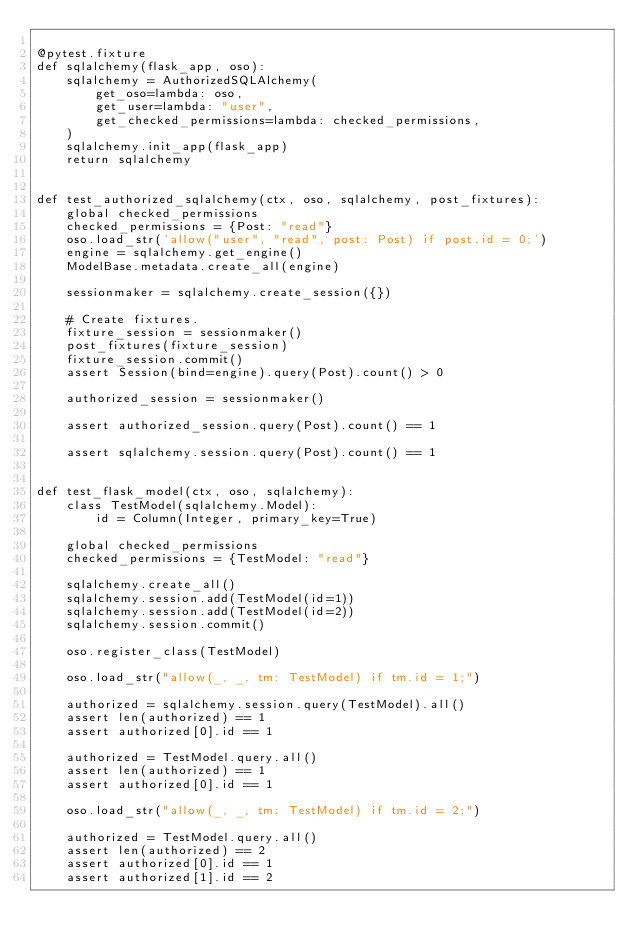<code> <loc_0><loc_0><loc_500><loc_500><_Python_>
@pytest.fixture
def sqlalchemy(flask_app, oso):
    sqlalchemy = AuthorizedSQLAlchemy(
        get_oso=lambda: oso,
        get_user=lambda: "user",
        get_checked_permissions=lambda: checked_permissions,
    )
    sqlalchemy.init_app(flask_app)
    return sqlalchemy


def test_authorized_sqlalchemy(ctx, oso, sqlalchemy, post_fixtures):
    global checked_permissions
    checked_permissions = {Post: "read"}
    oso.load_str('allow("user", "read", post: Post) if post.id = 0;')
    engine = sqlalchemy.get_engine()
    ModelBase.metadata.create_all(engine)

    sessionmaker = sqlalchemy.create_session({})

    # Create fixtures.
    fixture_session = sessionmaker()
    post_fixtures(fixture_session)
    fixture_session.commit()
    assert Session(bind=engine).query(Post).count() > 0

    authorized_session = sessionmaker()

    assert authorized_session.query(Post).count() == 1

    assert sqlalchemy.session.query(Post).count() == 1


def test_flask_model(ctx, oso, sqlalchemy):
    class TestModel(sqlalchemy.Model):
        id = Column(Integer, primary_key=True)

    global checked_permissions
    checked_permissions = {TestModel: "read"}

    sqlalchemy.create_all()
    sqlalchemy.session.add(TestModel(id=1))
    sqlalchemy.session.add(TestModel(id=2))
    sqlalchemy.session.commit()

    oso.register_class(TestModel)

    oso.load_str("allow(_, _, tm: TestModel) if tm.id = 1;")

    authorized = sqlalchemy.session.query(TestModel).all()
    assert len(authorized) == 1
    assert authorized[0].id == 1

    authorized = TestModel.query.all()
    assert len(authorized) == 1
    assert authorized[0].id == 1

    oso.load_str("allow(_, _, tm: TestModel) if tm.id = 2;")

    authorized = TestModel.query.all()
    assert len(authorized) == 2
    assert authorized[0].id == 1
    assert authorized[1].id == 2
</code> 